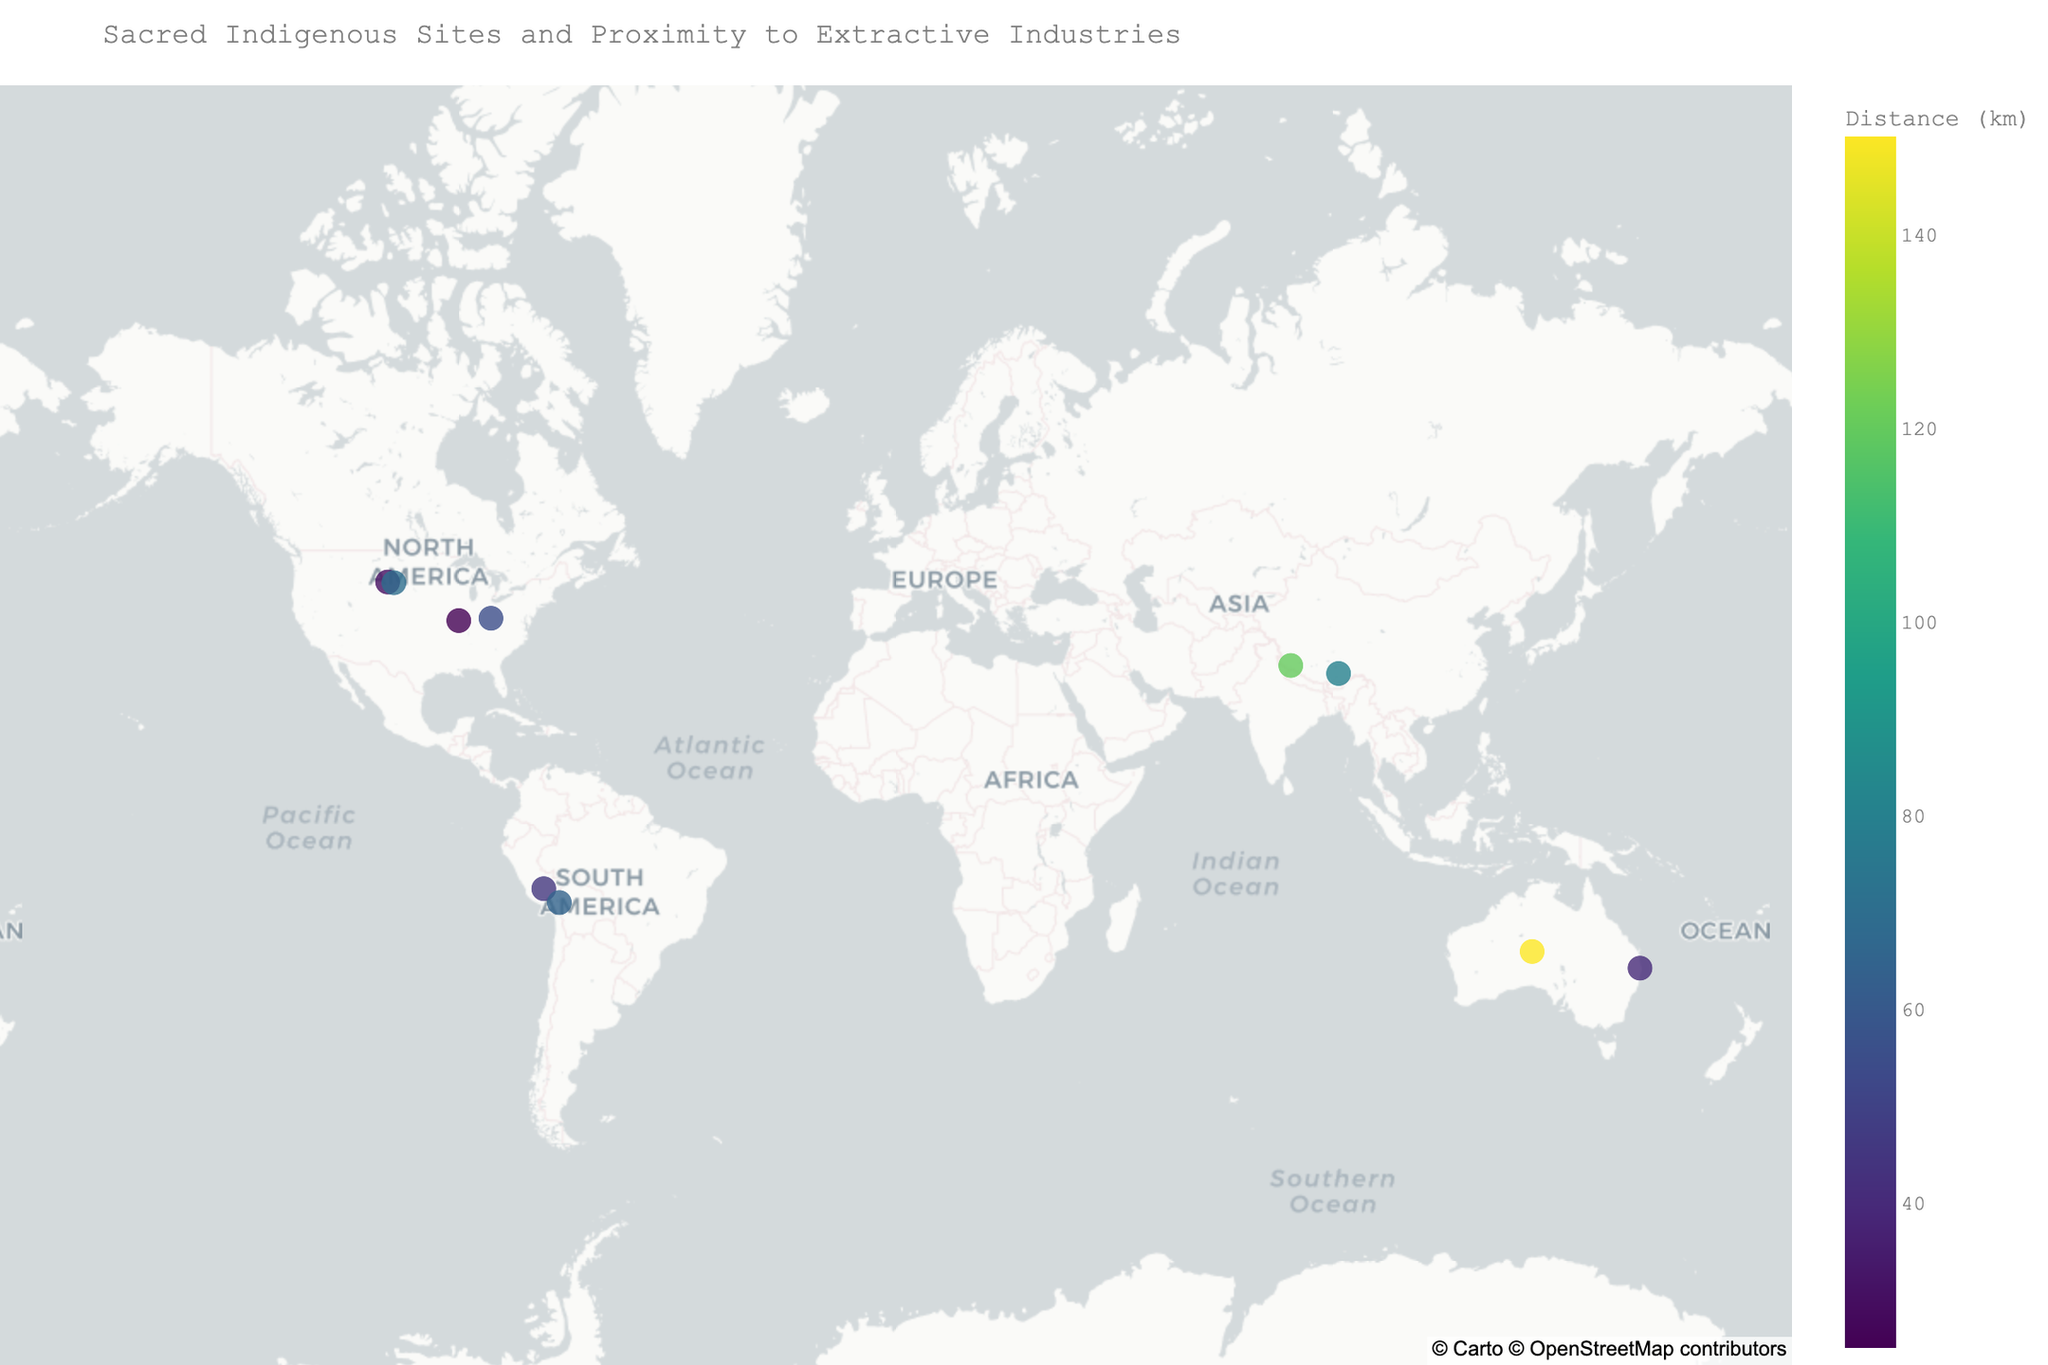What is the title of the map? The title is the text displayed prominently at the top of the map, summarizing its content. Here, it is "Sacred Indigenous Sites and Proximity to Extractive Industries."
Answer: Sacred Indigenous Sites and Proximity to Extractive Industries How many data points (sacred sites) are mapped on the figure? Each marker on the map represents a sacred site. By visually counting the markers, we find there are 10.
Answer: 10 Which sacred site is closest to an extractive industry and what is the industry? By looking at the data points, Cahokia Mounds appears closest to its nearest extractive industry, which is 25 km away from an oil refinery.
Answer: Cahokia Mounds, Oil Refinery Which sacred site has the greatest distance to an extractive industry, and what is the distance? By examining the color scale and markers, Uluru shows the greatest distance to its nearest extractive industry, which is 150 km away from a uranium mine.
Answer: Uluru, 150 km What's the sum of all the distances (in km) between the sacred sites and their nearest extractive industries? Summing up the distances from the figure's data points: 150 + 45 + 80 + 30 + 65 + 120 + 25 + 40 + 55 + 70 = 680 km.
Answer: 680 km What is the median distance (in km) from the sacred sites to their nearest extractive industries? Sorting the distances: 25, 30, 40, 45, 55, 65, 70, 80, 120, 150. The middle values of 55 and 65 yield (55 + 65)/2 = 60 km.
Answer: 60 km Which region (latitude and longitude) has the highest concentration of sacred sites? Concentration is inferred by the clustering of markers on the map. The highest concentration is around North America, particularly around latitudes 39 to 44 and longitudes -83 to -104.
Answer: North America Among the mapped sacred sites, which one is associated with the Quechua indigenous group? The map's information bubbles provide details. Machu Picchu is linked to the Quechua group.
Answer: Machu Picchu How does the distance to the nearest extractive industry vary across different sacred site types? Comparing the map markers, mountains like Uluru and Bear Butte show larger distances, whereas ancient cities like Cahokia Mounds and Machu Picchu have shorter distances.
Answer: Mountains: Larger, Ancient Cities: Shorter Which extractive industry appears most frequently near sacred sites on the map? By reviewing the industry names in the information bubbles, uranium mines appear twice, which is the most frequent.
Answer: Uranium Mine 